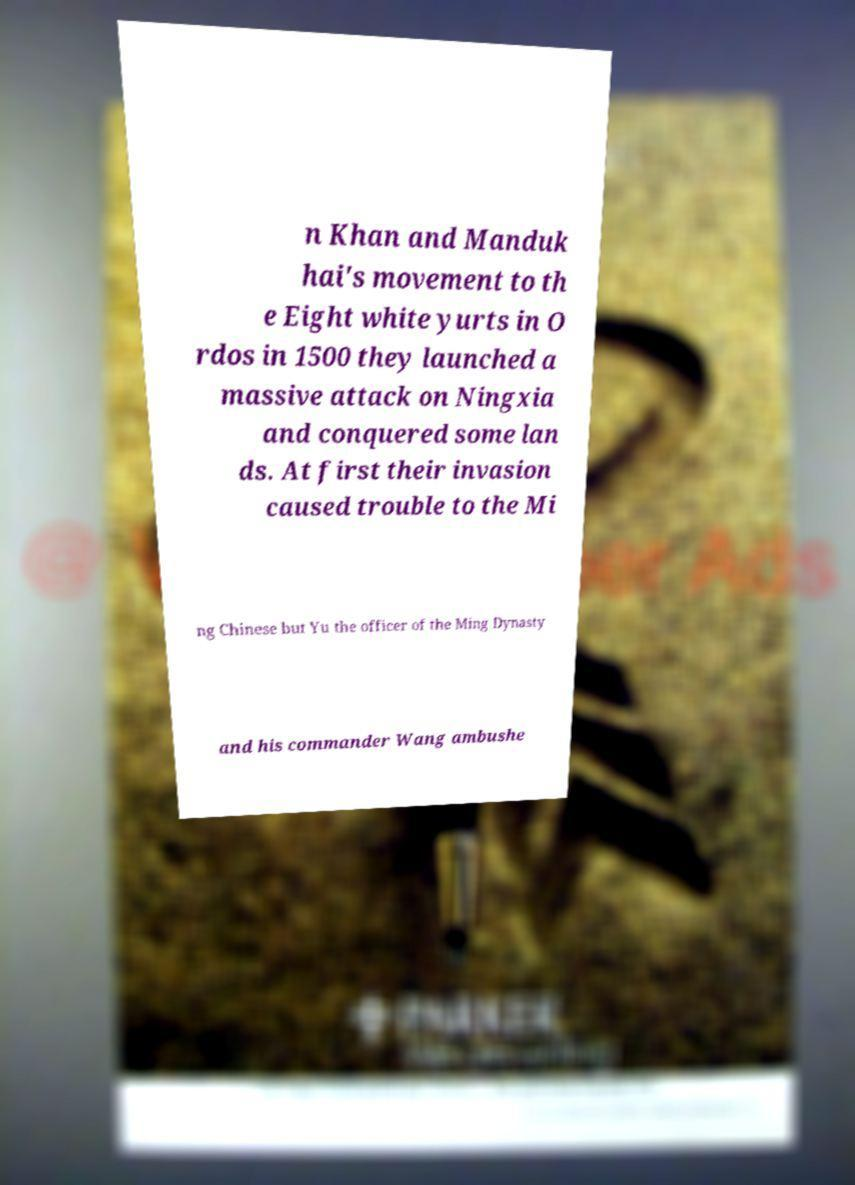There's text embedded in this image that I need extracted. Can you transcribe it verbatim? n Khan and Manduk hai's movement to th e Eight white yurts in O rdos in 1500 they launched a massive attack on Ningxia and conquered some lan ds. At first their invasion caused trouble to the Mi ng Chinese but Yu the officer of the Ming Dynasty and his commander Wang ambushe 